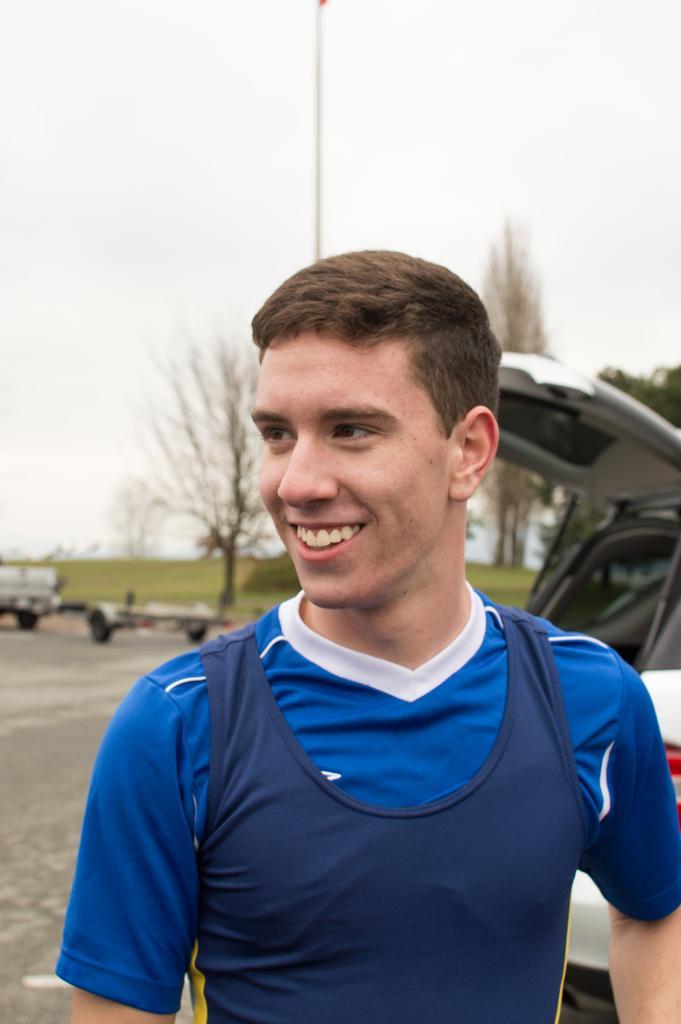Please provide a concise description of this image. In this image, we can see a person is smiling and look on the left side. Background there are few vehicles, road, trees, plants and grass. Here there is a pole and sky we can see. 